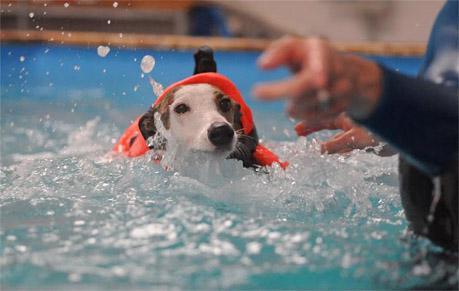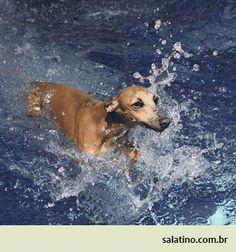The first image is the image on the left, the second image is the image on the right. Given the left and right images, does the statement "At least one dog is standing on land." hold true? Answer yes or no. No. 